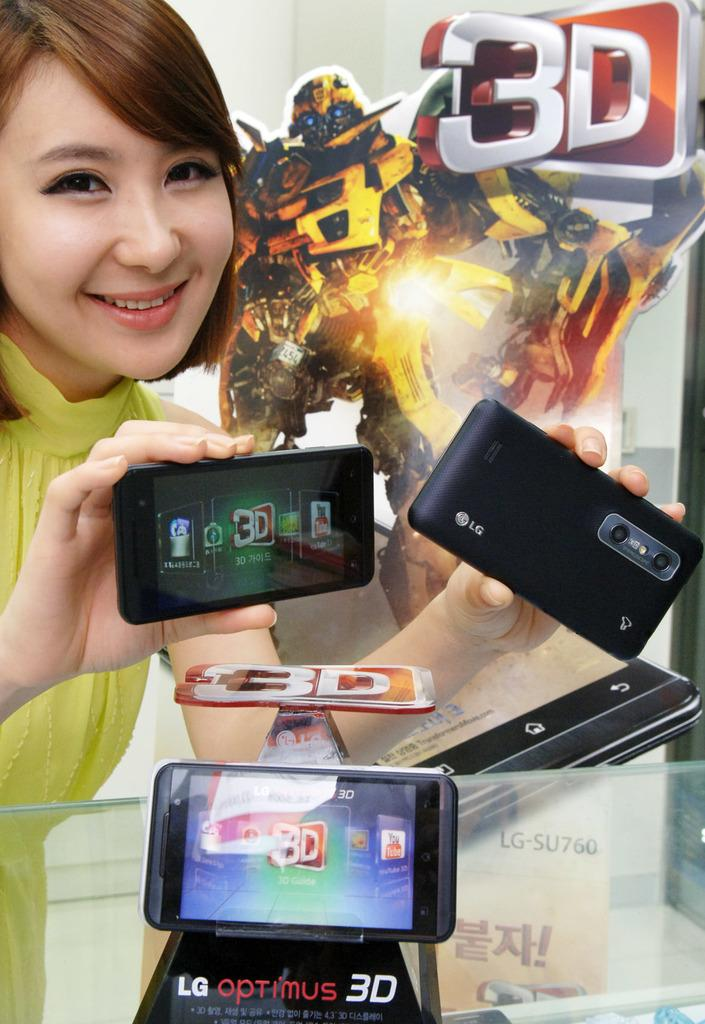<image>
Create a compact narrative representing the image presented. An Asian woman with short red-brown hair and a green shirt holds two LG Smartphones in her hands over a glass table with another smart phone set on it. 